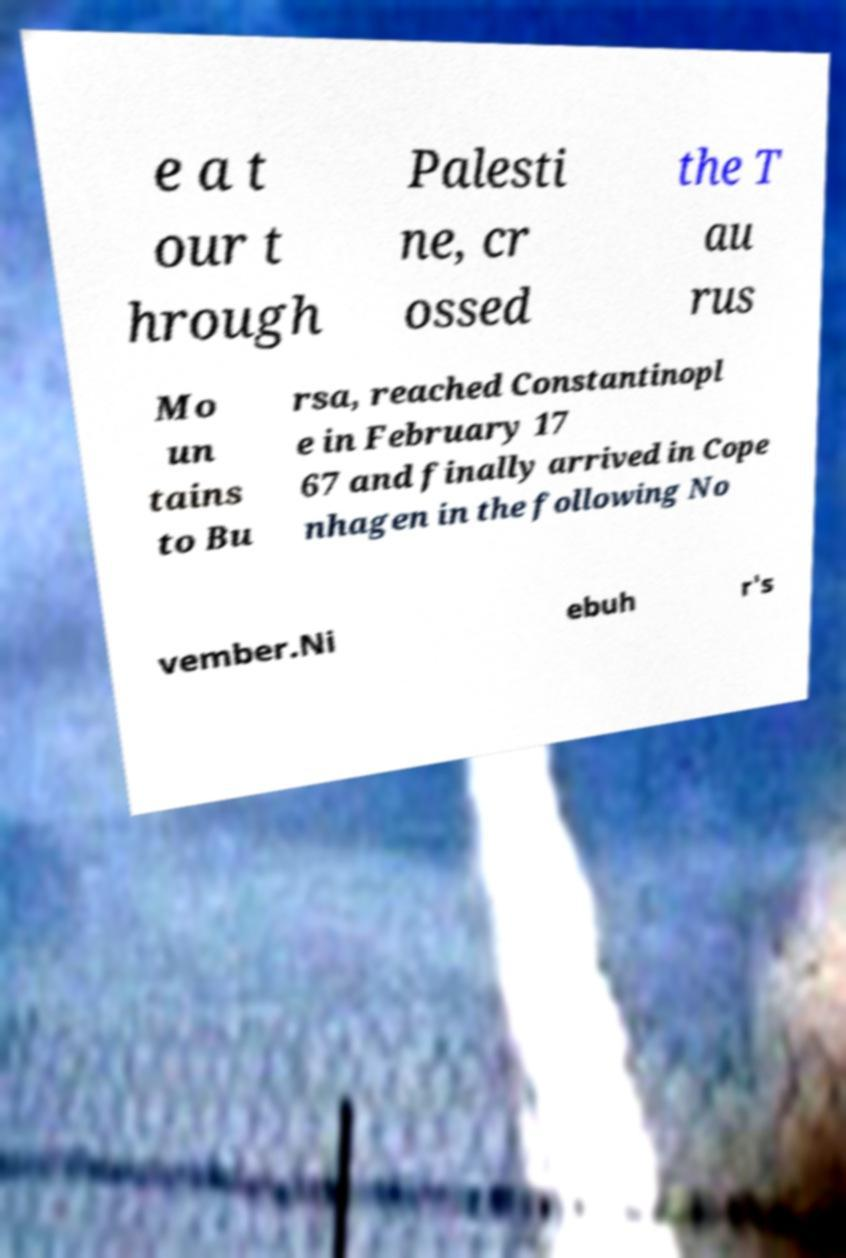Can you accurately transcribe the text from the provided image for me? e a t our t hrough Palesti ne, cr ossed the T au rus Mo un tains to Bu rsa, reached Constantinopl e in February 17 67 and finally arrived in Cope nhagen in the following No vember.Ni ebuh r's 